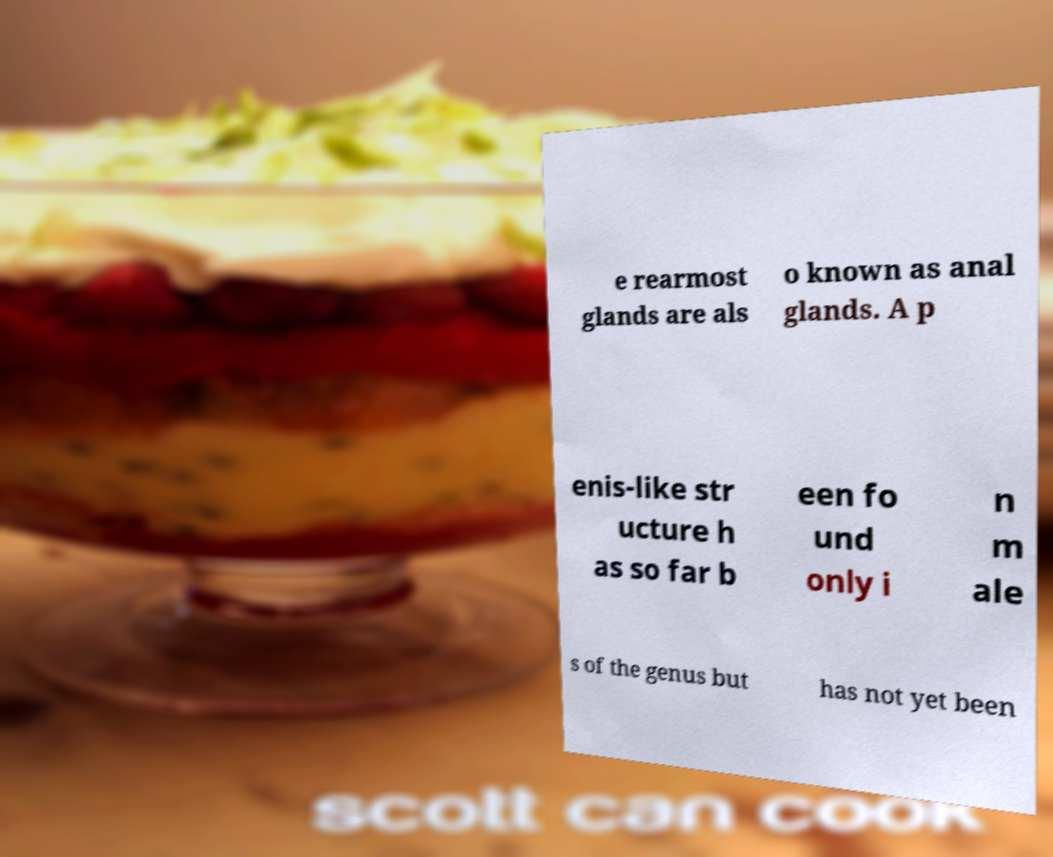Could you extract and type out the text from this image? e rearmost glands are als o known as anal glands. A p enis-like str ucture h as so far b een fo und only i n m ale s of the genus but has not yet been 